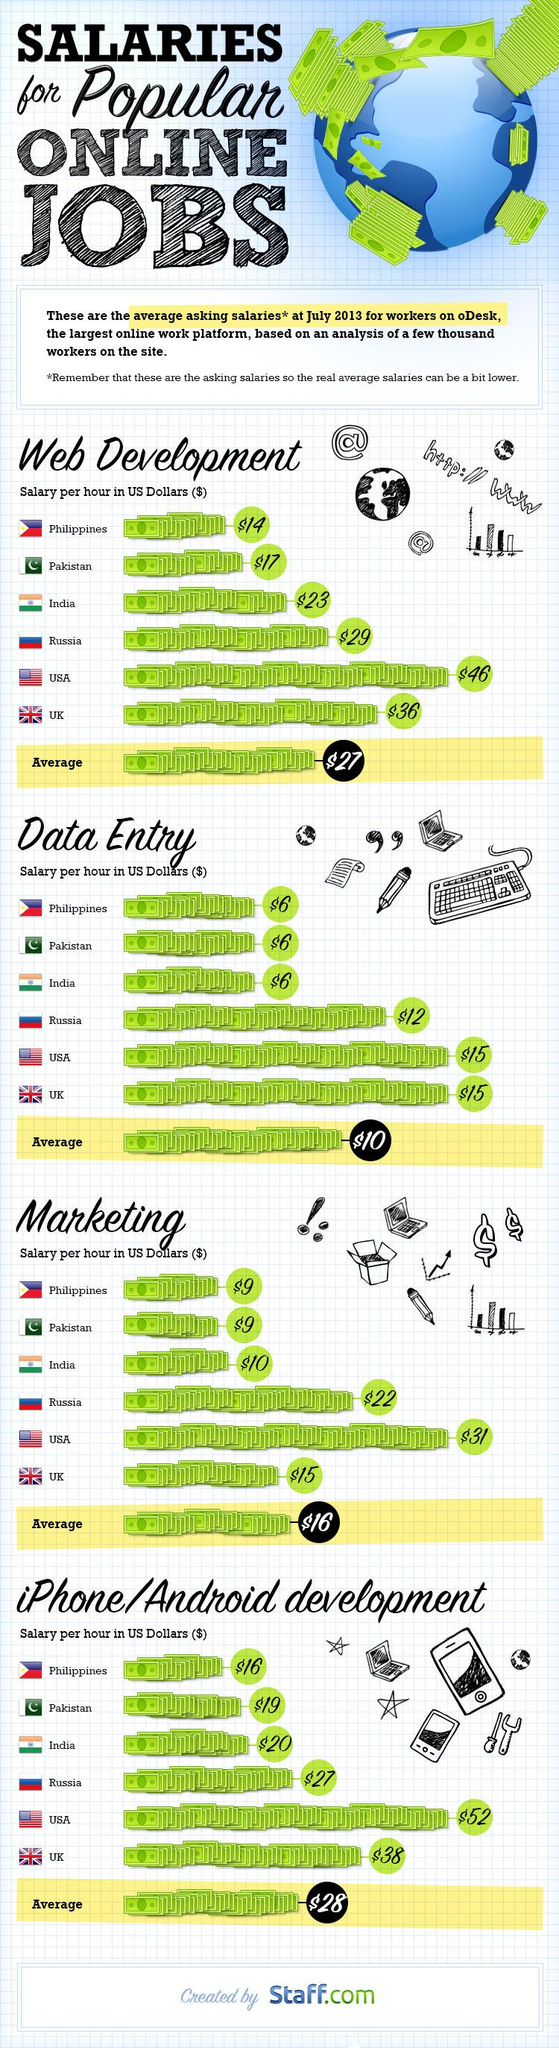List a handful of essential elements in this visual. According to the given information, the pay per hour in USD for web development in the USA is $17, while in India it is different. The total average pay for all categories of online jobs is $81. According to the data, Pakistan's median pay is lower for all four categories of online jobs compared to India. Six companies have been compared in the document. The country that pays the least salary per hour for web development, data entry, marketing, and Android development is the Philippines. 